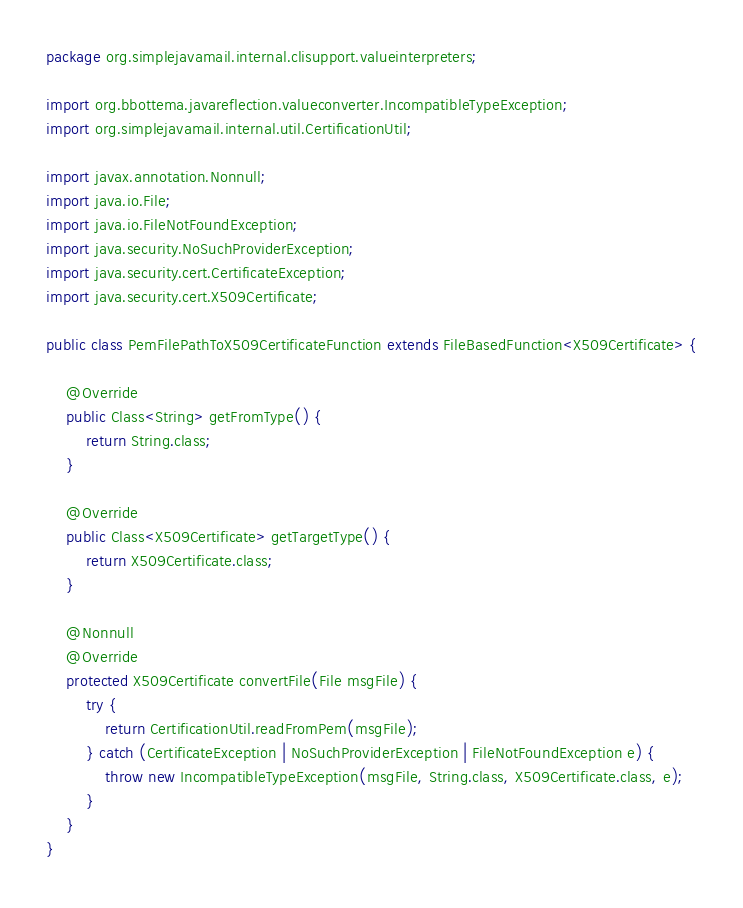<code> <loc_0><loc_0><loc_500><loc_500><_Java_>package org.simplejavamail.internal.clisupport.valueinterpreters;

import org.bbottema.javareflection.valueconverter.IncompatibleTypeException;
import org.simplejavamail.internal.util.CertificationUtil;

import javax.annotation.Nonnull;
import java.io.File;
import java.io.FileNotFoundException;
import java.security.NoSuchProviderException;
import java.security.cert.CertificateException;
import java.security.cert.X509Certificate;

public class PemFilePathToX509CertificateFunction extends FileBasedFunction<X509Certificate> {
	
	@Override
	public Class<String> getFromType() {
		return String.class;
	}
	
	@Override
	public Class<X509Certificate> getTargetType() {
		return X509Certificate.class;
	}
	
	@Nonnull
	@Override
	protected X509Certificate convertFile(File msgFile) {
		try {
			return CertificationUtil.readFromPem(msgFile);
		} catch (CertificateException | NoSuchProviderException | FileNotFoundException e) {
			throw new IncompatibleTypeException(msgFile, String.class, X509Certificate.class, e);
		}
	}
}</code> 